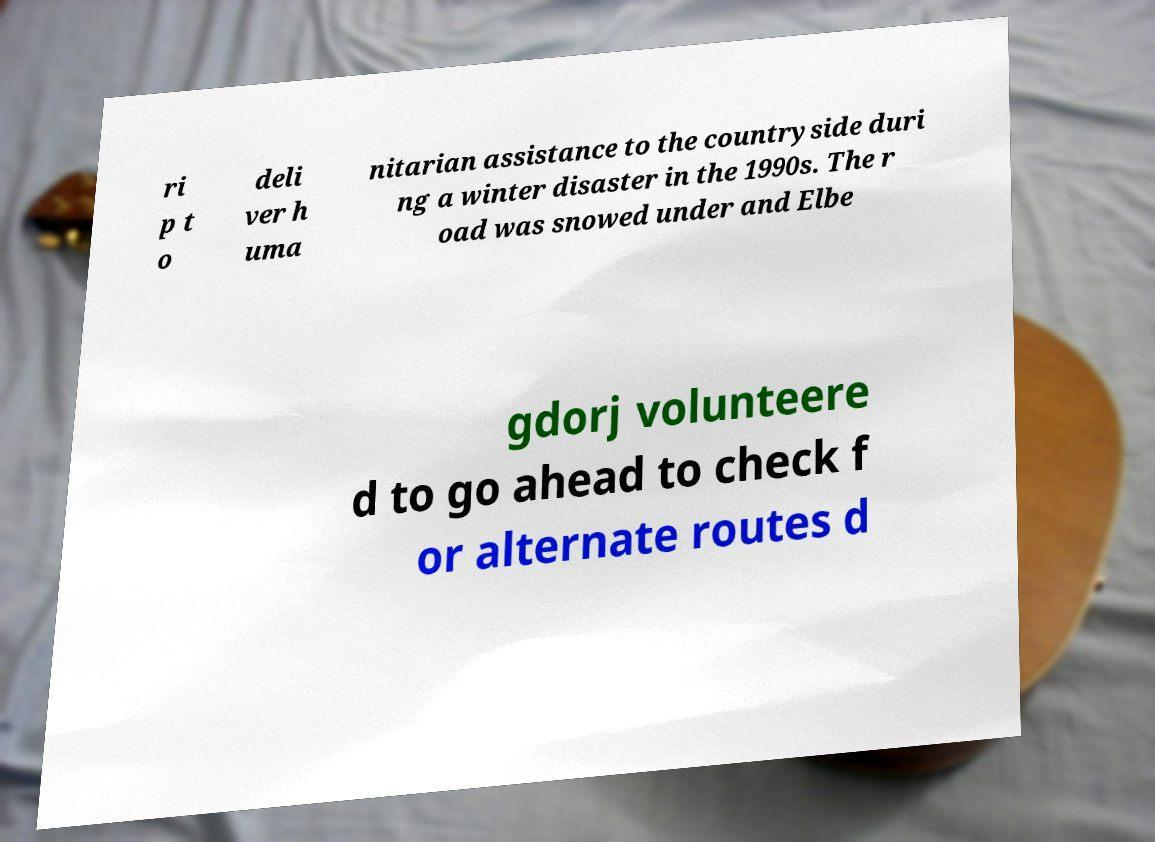Please identify and transcribe the text found in this image. ri p t o deli ver h uma nitarian assistance to the countryside duri ng a winter disaster in the 1990s. The r oad was snowed under and Elbe gdorj volunteere d to go ahead to check f or alternate routes d 